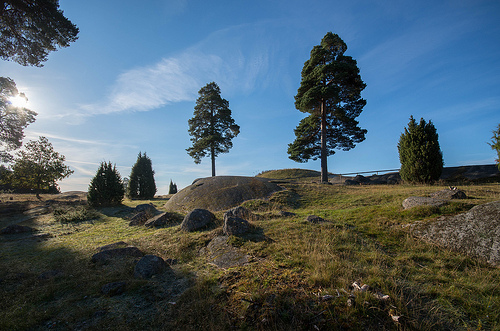<image>
Is there a tree to the left of the rock? No. The tree is not to the left of the rock. From this viewpoint, they have a different horizontal relationship. 